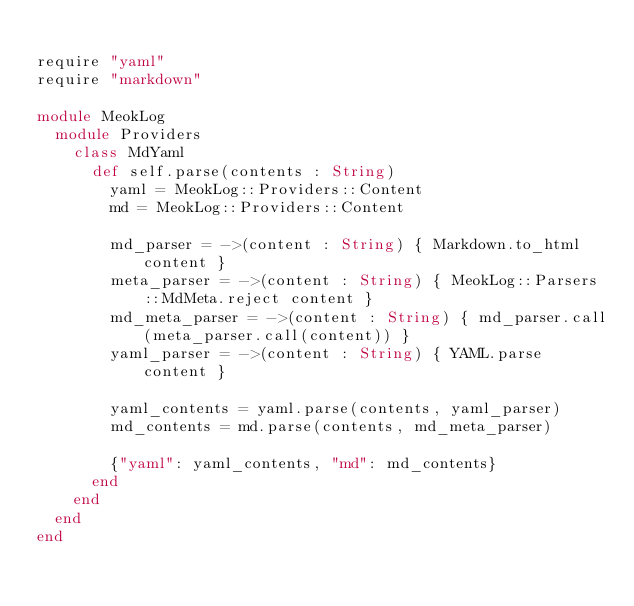<code> <loc_0><loc_0><loc_500><loc_500><_Crystal_>
require "yaml"
require "markdown"

module MeokLog
  module Providers
    class MdYaml
      def self.parse(contents : String)
        yaml = MeokLog::Providers::Content
        md = MeokLog::Providers::Content

        md_parser = ->(content : String) { Markdown.to_html content }
        meta_parser = ->(content : String) { MeokLog::Parsers::MdMeta.reject content }
        md_meta_parser = ->(content : String) { md_parser.call(meta_parser.call(content)) }
        yaml_parser = ->(content : String) { YAML.parse content }

        yaml_contents = yaml.parse(contents, yaml_parser)
        md_contents = md.parse(contents, md_meta_parser)

        {"yaml": yaml_contents, "md": md_contents}
      end
    end
  end
end
</code> 